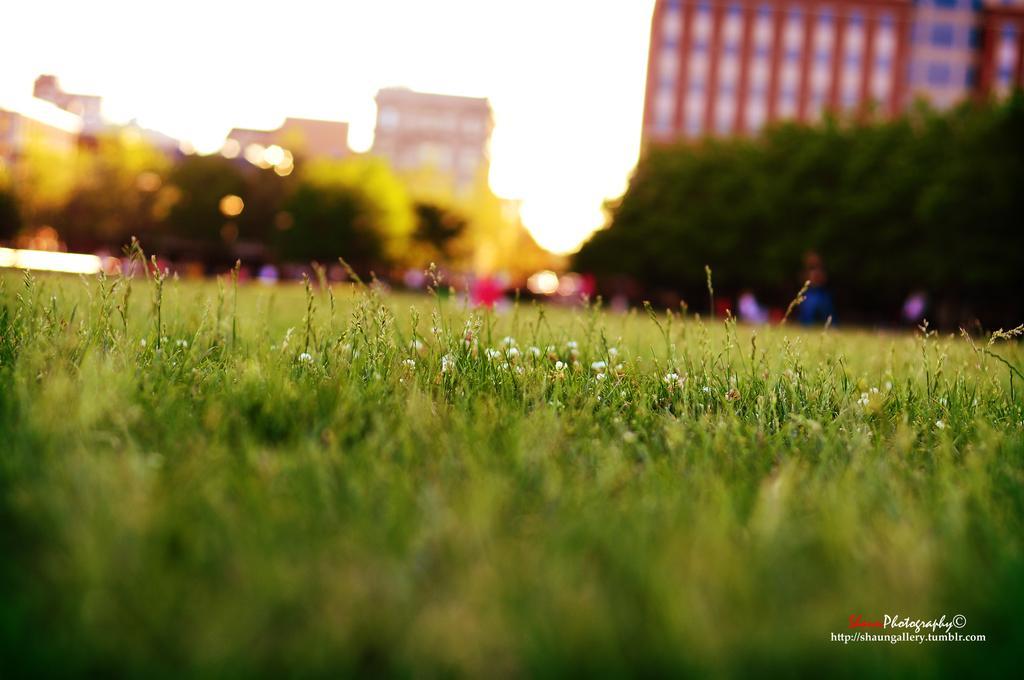Please provide a concise description of this image. This image is taken outdoors. At the top of the image there is the sky. In this image the background is a little blurred. There are a few buildings and there are a few trees. At the bottom of the image there is a ground with grass on it. 